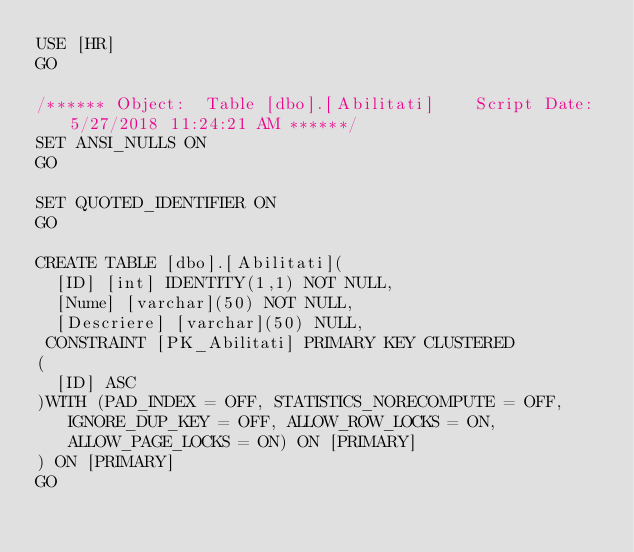<code> <loc_0><loc_0><loc_500><loc_500><_SQL_>USE [HR]
GO

/****** Object:  Table [dbo].[Abilitati]    Script Date: 5/27/2018 11:24:21 AM ******/
SET ANSI_NULLS ON
GO

SET QUOTED_IDENTIFIER ON
GO

CREATE TABLE [dbo].[Abilitati](
	[ID] [int] IDENTITY(1,1) NOT NULL,
	[Nume] [varchar](50) NOT NULL,
	[Descriere] [varchar](50) NULL,
 CONSTRAINT [PK_Abilitati] PRIMARY KEY CLUSTERED 
(
	[ID] ASC
)WITH (PAD_INDEX = OFF, STATISTICS_NORECOMPUTE = OFF, IGNORE_DUP_KEY = OFF, ALLOW_ROW_LOCKS = ON, ALLOW_PAGE_LOCKS = ON) ON [PRIMARY]
) ON [PRIMARY]
GO

</code> 